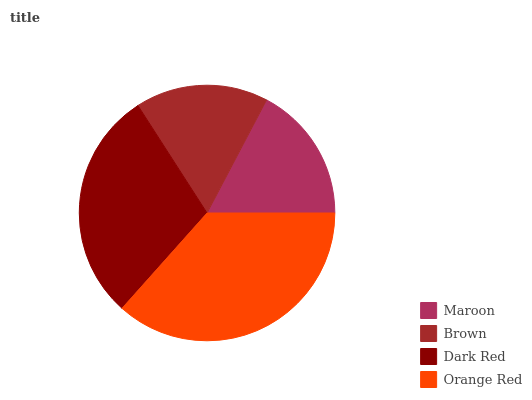Is Brown the minimum?
Answer yes or no. Yes. Is Orange Red the maximum?
Answer yes or no. Yes. Is Dark Red the minimum?
Answer yes or no. No. Is Dark Red the maximum?
Answer yes or no. No. Is Dark Red greater than Brown?
Answer yes or no. Yes. Is Brown less than Dark Red?
Answer yes or no. Yes. Is Brown greater than Dark Red?
Answer yes or no. No. Is Dark Red less than Brown?
Answer yes or no. No. Is Dark Red the high median?
Answer yes or no. Yes. Is Maroon the low median?
Answer yes or no. Yes. Is Maroon the high median?
Answer yes or no. No. Is Brown the low median?
Answer yes or no. No. 